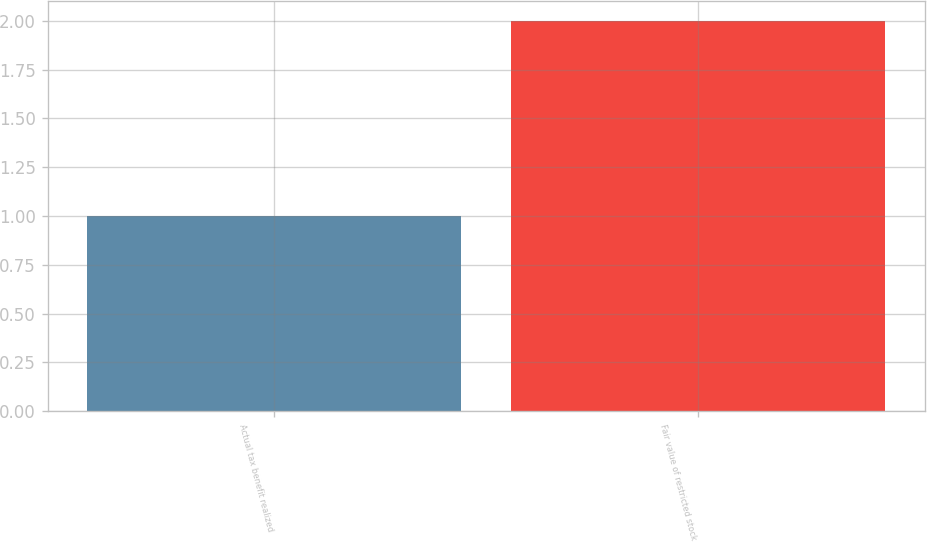<chart> <loc_0><loc_0><loc_500><loc_500><bar_chart><fcel>Actual tax benefit realized<fcel>Fair value of restricted stock<nl><fcel>1<fcel>2<nl></chart> 